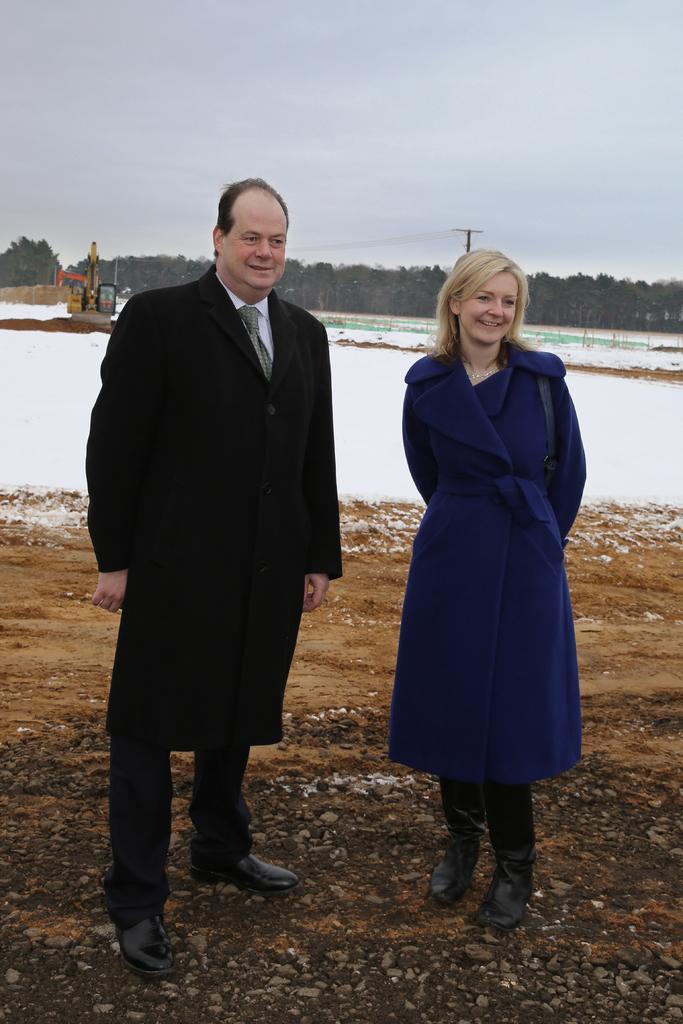Describe this image in one or two sentences. In this image I can see on the left side a man is standing, he wore black color coat, trouser, shoes. On the right side a beautiful woman is standing, she wore blue color coat. Behind them there is the snow, at the top it is the sky. 